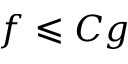Convert formula to latex. <formula><loc_0><loc_0><loc_500><loc_500>f \leqslant C g</formula> 